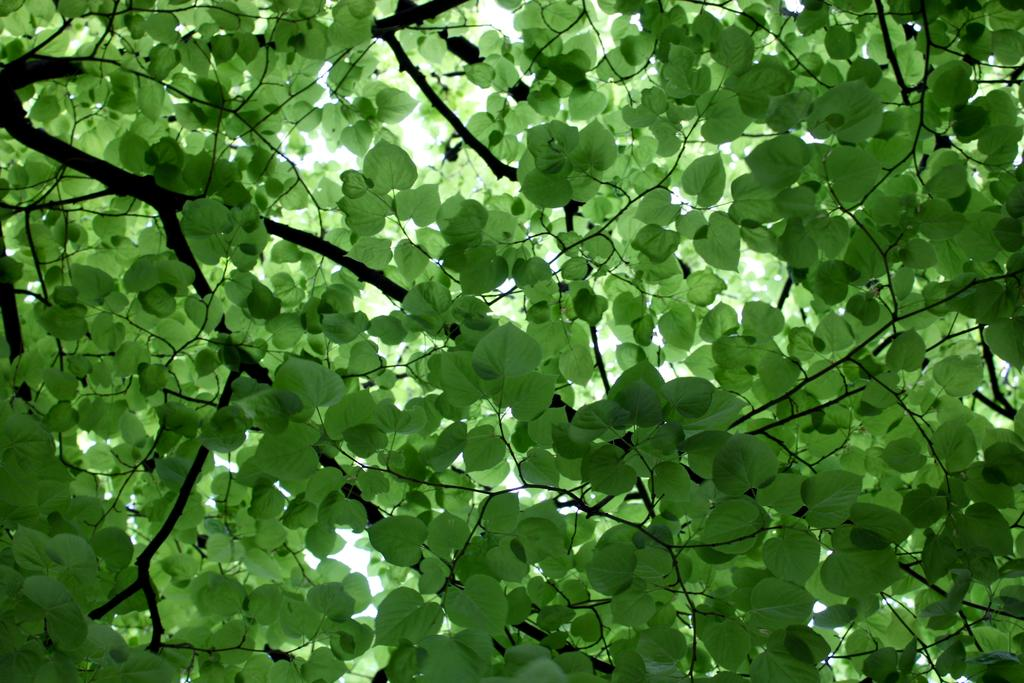What type of vegetation is present in the image? There are green leaves in the image. What part of a tree can be seen in the image? There are branches of a tree in the image. What type of committee is meeting under the tree in the image? There is no committee meeting under the tree in the image; it only shows green leaves and branches of a tree. 